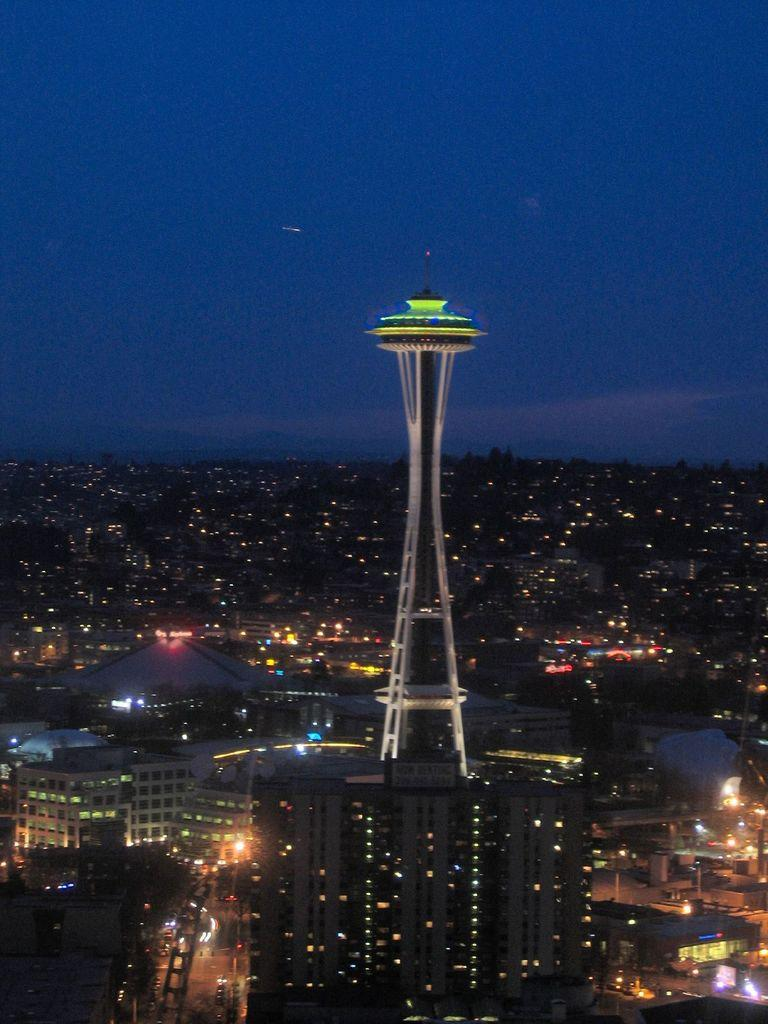What type of location is depicted in the image? The image is of a city. What structures can be seen in the city? There are buildings and a tower in the image. What are the poles used for in the image? The purpose of the poles is not specified, but they could be for streetlights, traffic signals, or other utilities. What is moving on the roads in the image? There are vehicles on the road in the image. What is visible at the top of the image? The sky is visible at the top of the image, and there are clouds in the sky. What type of fowl can be seen perched on the tower in the image? There are no fowl visible in the image, and no fowl is perched on the tower. What is the hammer used for in the image? There is no hammer present in the image. 